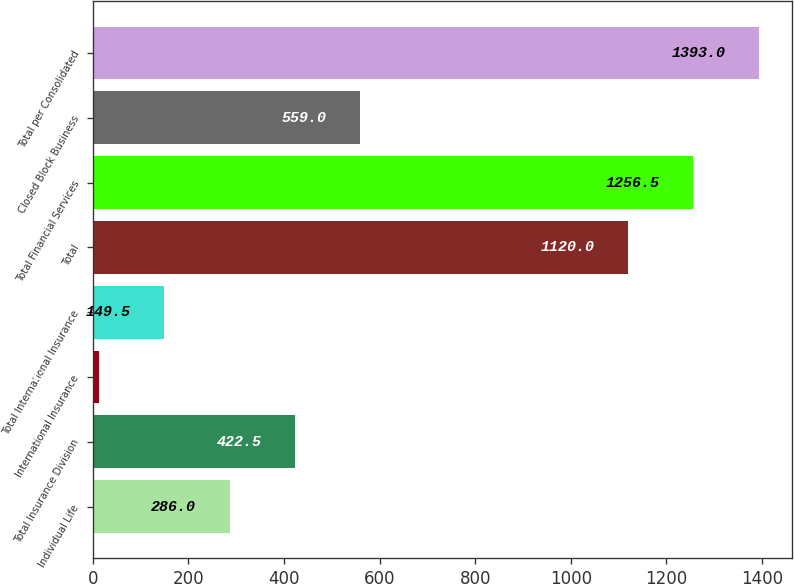<chart> <loc_0><loc_0><loc_500><loc_500><bar_chart><fcel>Individual Life<fcel>Total Insurance Division<fcel>International Insurance<fcel>Total International Insurance<fcel>Total<fcel>Total Financial Services<fcel>Closed Block Business<fcel>Total per Consolidated<nl><fcel>286<fcel>422.5<fcel>13<fcel>149.5<fcel>1120<fcel>1256.5<fcel>559<fcel>1393<nl></chart> 